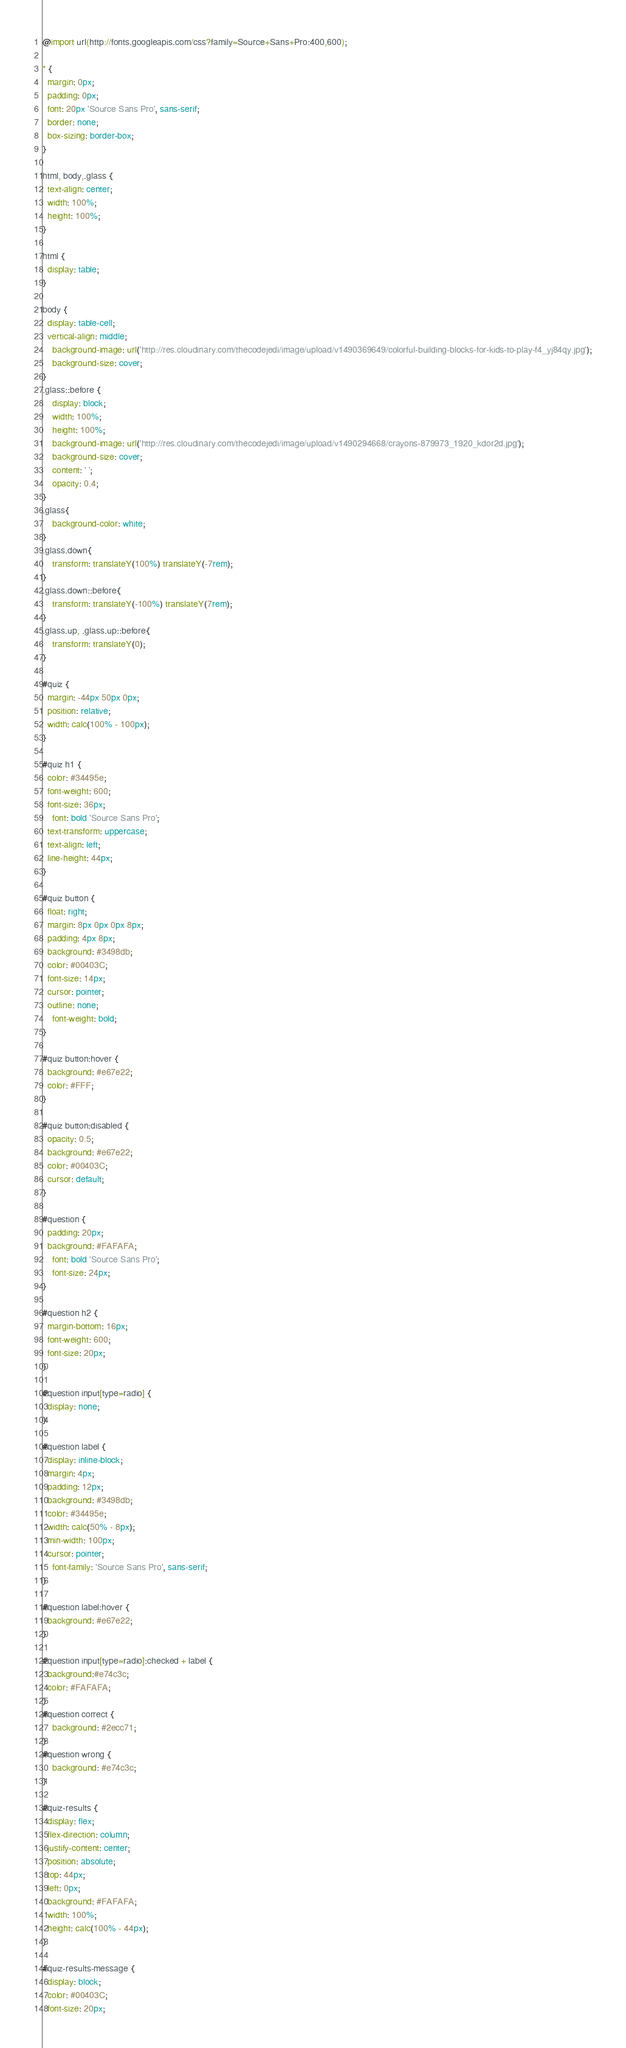<code> <loc_0><loc_0><loc_500><loc_500><_CSS_>@import url(http://fonts.googleapis.com/css?family=Source+Sans+Pro:400,600);

* {
  margin: 0px;
  padding: 0px;
  font: 20px 'Source Sans Pro', sans-serif;
  border: none;
  box-sizing: border-box;
}

html, body,.glass {
  text-align: center;
  width: 100%;
  height: 100%;
}

html {
  display: table;
}

body {
  display: table-cell;
  vertical-align: middle;
	background-image: url('http://res.cloudinary.com/thecodejedi/image/upload/v1490369649/colorful-building-blocks-for-kids-to-play-f4_yj84qy.jpg');
	background-size: cover;
}
.glass::before {
	display: block;
	width: 100%;
	height: 100%;
	background-image: url('http://res.cloudinary.com/thecodejedi/image/upload/v1490294668/crayons-879973_1920_kdor2d.jpg');
	background-size: cover;
	content: ' ';
	opacity: 0.4;
}
.glass{
	background-color: white;
}
.glass.down{
	transform: translateY(100%) translateY(-7rem);
}
.glass.down::before{
	transform: translateY(-100%) translateY(7rem);
}
.glass.up, .glass.up::before{
	transform: translateY(0);
}

#quiz {
  margin: -44px 50px 0px;
  position: relative;
  width: calc(100% - 100px);
}

#quiz h1 {
  color: #34495e;
  font-weight: 600;
  font-size: 36px;
	font: bold 'Source Sans Pro';
  text-transform: uppercase;
  text-align: left;
  line-height: 44px;
}

#quiz button {
  float: right;
  margin: 8px 0px 0px 8px;
  padding: 4px 8px;
  background: #3498db;
  color: #00403C;
  font-size: 14px;
  cursor: pointer;
  outline: none;
	font-weight: bold;
}

#quiz button:hover {
  background: #e67e22;
  color: #FFF;
}

#quiz button:disabled {
  opacity: 0.5;
  background: #e67e22;
  color: #00403C;
  cursor: default;
}

#question {
  padding: 20px;
  background: #FAFAFA;
	font: bold 'Source Sans Pro';
	font-size: 24px;
}

#question h2 {
  margin-bottom: 16px;
  font-weight: 600;
  font-size: 20px;
}

#question input[type=radio] {
  display: none;
}

#question label {
  display: inline-block;
  margin: 4px;
  padding: 12px;
  background: #3498db;
  color: #34495e;
  width: calc(50% - 8px);
  min-width: 100px;
  cursor: pointer;
	font-family: 'Source Sans Pro', sans-serif;
}

#question label:hover {
  background: #e67e22;
}

#question input[type=radio]:checked + label {
  background:#e74c3c;
  color: #FAFAFA;
}
#question correct {
	background: #2ecc71;
}
#question wrong {
	background: #e74c3c;
}

#quiz-results {
  display: flex;
  flex-direction: column;
  justify-content: center;
  position: absolute;
  top: 44px;
  left: 0px;
  background: #FAFAFA;
  width: 100%;
  height: calc(100% - 44px);
}

#quiz-results-message {
  display: block;
  color: #00403C;
  font-size: 20px;</code> 